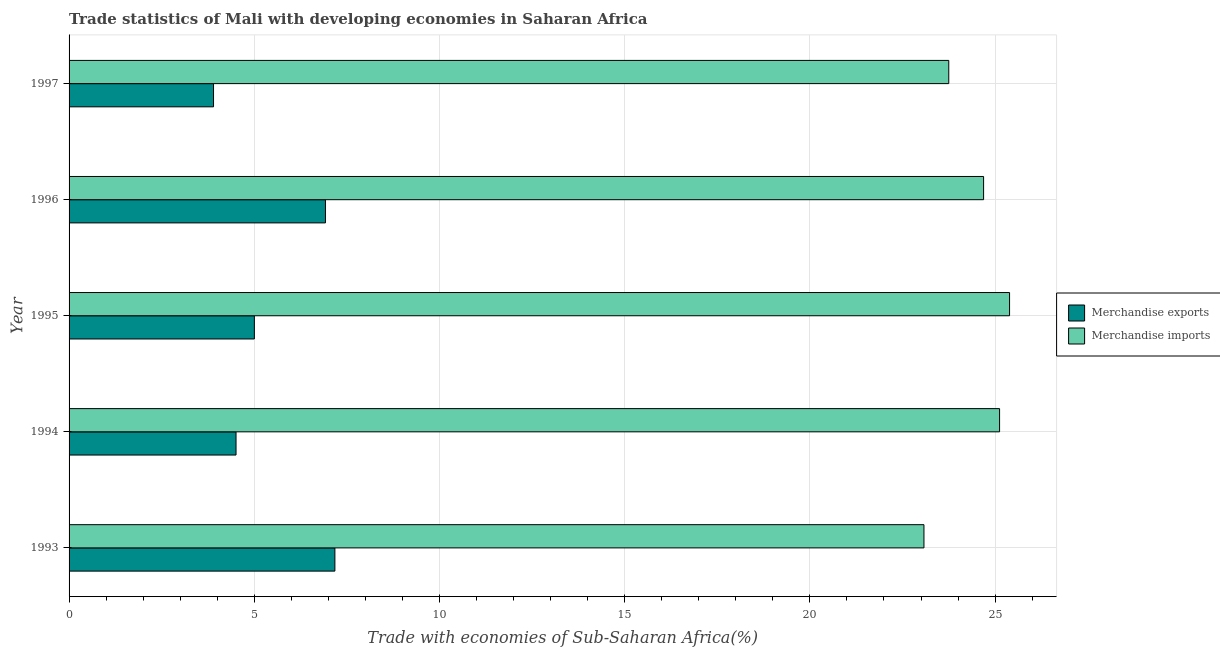How many groups of bars are there?
Offer a very short reply. 5. Are the number of bars per tick equal to the number of legend labels?
Make the answer very short. Yes. How many bars are there on the 1st tick from the top?
Offer a terse response. 2. How many bars are there on the 1st tick from the bottom?
Keep it short and to the point. 2. What is the label of the 2nd group of bars from the top?
Offer a very short reply. 1996. What is the merchandise exports in 1994?
Your answer should be very brief. 4.51. Across all years, what is the maximum merchandise imports?
Provide a short and direct response. 25.39. Across all years, what is the minimum merchandise imports?
Ensure brevity in your answer.  23.08. In which year was the merchandise exports maximum?
Give a very brief answer. 1993. What is the total merchandise exports in the graph?
Your answer should be very brief. 27.51. What is the difference between the merchandise imports in 1994 and that in 1996?
Provide a succinct answer. 0.43. What is the difference between the merchandise exports in 1994 and the merchandise imports in 1996?
Your answer should be very brief. -20.18. What is the average merchandise exports per year?
Make the answer very short. 5.5. In the year 1993, what is the difference between the merchandise exports and merchandise imports?
Your answer should be very brief. -15.9. What is the ratio of the merchandise exports in 1994 to that in 1997?
Ensure brevity in your answer.  1.16. Is the difference between the merchandise exports in 1995 and 1997 greater than the difference between the merchandise imports in 1995 and 1997?
Offer a very short reply. No. What is the difference between the highest and the second highest merchandise exports?
Offer a very short reply. 0.26. What is the difference between the highest and the lowest merchandise imports?
Your response must be concise. 2.31. In how many years, is the merchandise exports greater than the average merchandise exports taken over all years?
Keep it short and to the point. 2. Is the sum of the merchandise exports in 1993 and 1994 greater than the maximum merchandise imports across all years?
Ensure brevity in your answer.  No. What does the 1st bar from the bottom in 1993 represents?
Offer a very short reply. Merchandise exports. Are the values on the major ticks of X-axis written in scientific E-notation?
Your answer should be very brief. No. Does the graph contain grids?
Provide a short and direct response. Yes. Where does the legend appear in the graph?
Ensure brevity in your answer.  Center right. How many legend labels are there?
Your response must be concise. 2. What is the title of the graph?
Make the answer very short. Trade statistics of Mali with developing economies in Saharan Africa. What is the label or title of the X-axis?
Give a very brief answer. Trade with economies of Sub-Saharan Africa(%). What is the Trade with economies of Sub-Saharan Africa(%) in Merchandise exports in 1993?
Give a very brief answer. 7.18. What is the Trade with economies of Sub-Saharan Africa(%) of Merchandise imports in 1993?
Offer a very short reply. 23.08. What is the Trade with economies of Sub-Saharan Africa(%) of Merchandise exports in 1994?
Provide a succinct answer. 4.51. What is the Trade with economies of Sub-Saharan Africa(%) in Merchandise imports in 1994?
Make the answer very short. 25.12. What is the Trade with economies of Sub-Saharan Africa(%) of Merchandise exports in 1995?
Offer a very short reply. 5. What is the Trade with economies of Sub-Saharan Africa(%) of Merchandise imports in 1995?
Offer a very short reply. 25.39. What is the Trade with economies of Sub-Saharan Africa(%) in Merchandise exports in 1996?
Your answer should be very brief. 6.92. What is the Trade with economies of Sub-Saharan Africa(%) of Merchandise imports in 1996?
Your answer should be compact. 24.69. What is the Trade with economies of Sub-Saharan Africa(%) of Merchandise exports in 1997?
Make the answer very short. 3.9. What is the Trade with economies of Sub-Saharan Africa(%) in Merchandise imports in 1997?
Your answer should be very brief. 23.75. Across all years, what is the maximum Trade with economies of Sub-Saharan Africa(%) in Merchandise exports?
Ensure brevity in your answer.  7.18. Across all years, what is the maximum Trade with economies of Sub-Saharan Africa(%) of Merchandise imports?
Your answer should be compact. 25.39. Across all years, what is the minimum Trade with economies of Sub-Saharan Africa(%) of Merchandise exports?
Provide a short and direct response. 3.9. Across all years, what is the minimum Trade with economies of Sub-Saharan Africa(%) in Merchandise imports?
Your answer should be very brief. 23.08. What is the total Trade with economies of Sub-Saharan Africa(%) of Merchandise exports in the graph?
Your answer should be compact. 27.51. What is the total Trade with economies of Sub-Saharan Africa(%) in Merchandise imports in the graph?
Your response must be concise. 122.03. What is the difference between the Trade with economies of Sub-Saharan Africa(%) in Merchandise exports in 1993 and that in 1994?
Make the answer very short. 2.67. What is the difference between the Trade with economies of Sub-Saharan Africa(%) of Merchandise imports in 1993 and that in 1994?
Give a very brief answer. -2.04. What is the difference between the Trade with economies of Sub-Saharan Africa(%) of Merchandise exports in 1993 and that in 1995?
Your response must be concise. 2.17. What is the difference between the Trade with economies of Sub-Saharan Africa(%) in Merchandise imports in 1993 and that in 1995?
Provide a short and direct response. -2.31. What is the difference between the Trade with economies of Sub-Saharan Africa(%) in Merchandise exports in 1993 and that in 1996?
Ensure brevity in your answer.  0.25. What is the difference between the Trade with economies of Sub-Saharan Africa(%) in Merchandise imports in 1993 and that in 1996?
Provide a short and direct response. -1.61. What is the difference between the Trade with economies of Sub-Saharan Africa(%) of Merchandise exports in 1993 and that in 1997?
Keep it short and to the point. 3.28. What is the difference between the Trade with economies of Sub-Saharan Africa(%) of Merchandise imports in 1993 and that in 1997?
Make the answer very short. -0.67. What is the difference between the Trade with economies of Sub-Saharan Africa(%) of Merchandise exports in 1994 and that in 1995?
Provide a succinct answer. -0.49. What is the difference between the Trade with economies of Sub-Saharan Africa(%) of Merchandise imports in 1994 and that in 1995?
Your answer should be compact. -0.27. What is the difference between the Trade with economies of Sub-Saharan Africa(%) in Merchandise exports in 1994 and that in 1996?
Give a very brief answer. -2.41. What is the difference between the Trade with economies of Sub-Saharan Africa(%) of Merchandise imports in 1994 and that in 1996?
Your answer should be compact. 0.43. What is the difference between the Trade with economies of Sub-Saharan Africa(%) of Merchandise exports in 1994 and that in 1997?
Provide a short and direct response. 0.61. What is the difference between the Trade with economies of Sub-Saharan Africa(%) of Merchandise imports in 1994 and that in 1997?
Provide a short and direct response. 1.37. What is the difference between the Trade with economies of Sub-Saharan Africa(%) in Merchandise exports in 1995 and that in 1996?
Ensure brevity in your answer.  -1.92. What is the difference between the Trade with economies of Sub-Saharan Africa(%) of Merchandise imports in 1995 and that in 1996?
Your response must be concise. 0.7. What is the difference between the Trade with economies of Sub-Saharan Africa(%) of Merchandise exports in 1995 and that in 1997?
Provide a short and direct response. 1.1. What is the difference between the Trade with economies of Sub-Saharan Africa(%) of Merchandise imports in 1995 and that in 1997?
Provide a short and direct response. 1.64. What is the difference between the Trade with economies of Sub-Saharan Africa(%) in Merchandise exports in 1996 and that in 1997?
Offer a terse response. 3.02. What is the difference between the Trade with economies of Sub-Saharan Africa(%) of Merchandise imports in 1996 and that in 1997?
Ensure brevity in your answer.  0.94. What is the difference between the Trade with economies of Sub-Saharan Africa(%) of Merchandise exports in 1993 and the Trade with economies of Sub-Saharan Africa(%) of Merchandise imports in 1994?
Give a very brief answer. -17.94. What is the difference between the Trade with economies of Sub-Saharan Africa(%) in Merchandise exports in 1993 and the Trade with economies of Sub-Saharan Africa(%) in Merchandise imports in 1995?
Your response must be concise. -18.21. What is the difference between the Trade with economies of Sub-Saharan Africa(%) in Merchandise exports in 1993 and the Trade with economies of Sub-Saharan Africa(%) in Merchandise imports in 1996?
Offer a very short reply. -17.51. What is the difference between the Trade with economies of Sub-Saharan Africa(%) of Merchandise exports in 1993 and the Trade with economies of Sub-Saharan Africa(%) of Merchandise imports in 1997?
Offer a terse response. -16.57. What is the difference between the Trade with economies of Sub-Saharan Africa(%) in Merchandise exports in 1994 and the Trade with economies of Sub-Saharan Africa(%) in Merchandise imports in 1995?
Provide a succinct answer. -20.88. What is the difference between the Trade with economies of Sub-Saharan Africa(%) in Merchandise exports in 1994 and the Trade with economies of Sub-Saharan Africa(%) in Merchandise imports in 1996?
Provide a short and direct response. -20.18. What is the difference between the Trade with economies of Sub-Saharan Africa(%) in Merchandise exports in 1994 and the Trade with economies of Sub-Saharan Africa(%) in Merchandise imports in 1997?
Offer a very short reply. -19.24. What is the difference between the Trade with economies of Sub-Saharan Africa(%) in Merchandise exports in 1995 and the Trade with economies of Sub-Saharan Africa(%) in Merchandise imports in 1996?
Offer a very short reply. -19.69. What is the difference between the Trade with economies of Sub-Saharan Africa(%) in Merchandise exports in 1995 and the Trade with economies of Sub-Saharan Africa(%) in Merchandise imports in 1997?
Your answer should be very brief. -18.75. What is the difference between the Trade with economies of Sub-Saharan Africa(%) of Merchandise exports in 1996 and the Trade with economies of Sub-Saharan Africa(%) of Merchandise imports in 1997?
Provide a succinct answer. -16.83. What is the average Trade with economies of Sub-Saharan Africa(%) of Merchandise exports per year?
Make the answer very short. 5.5. What is the average Trade with economies of Sub-Saharan Africa(%) of Merchandise imports per year?
Your answer should be very brief. 24.41. In the year 1993, what is the difference between the Trade with economies of Sub-Saharan Africa(%) of Merchandise exports and Trade with economies of Sub-Saharan Africa(%) of Merchandise imports?
Your answer should be compact. -15.9. In the year 1994, what is the difference between the Trade with economies of Sub-Saharan Africa(%) in Merchandise exports and Trade with economies of Sub-Saharan Africa(%) in Merchandise imports?
Your answer should be compact. -20.61. In the year 1995, what is the difference between the Trade with economies of Sub-Saharan Africa(%) of Merchandise exports and Trade with economies of Sub-Saharan Africa(%) of Merchandise imports?
Ensure brevity in your answer.  -20.39. In the year 1996, what is the difference between the Trade with economies of Sub-Saharan Africa(%) of Merchandise exports and Trade with economies of Sub-Saharan Africa(%) of Merchandise imports?
Your answer should be very brief. -17.77. In the year 1997, what is the difference between the Trade with economies of Sub-Saharan Africa(%) of Merchandise exports and Trade with economies of Sub-Saharan Africa(%) of Merchandise imports?
Provide a short and direct response. -19.85. What is the ratio of the Trade with economies of Sub-Saharan Africa(%) in Merchandise exports in 1993 to that in 1994?
Provide a short and direct response. 1.59. What is the ratio of the Trade with economies of Sub-Saharan Africa(%) in Merchandise imports in 1993 to that in 1994?
Provide a short and direct response. 0.92. What is the ratio of the Trade with economies of Sub-Saharan Africa(%) in Merchandise exports in 1993 to that in 1995?
Ensure brevity in your answer.  1.43. What is the ratio of the Trade with economies of Sub-Saharan Africa(%) in Merchandise imports in 1993 to that in 1995?
Give a very brief answer. 0.91. What is the ratio of the Trade with economies of Sub-Saharan Africa(%) of Merchandise exports in 1993 to that in 1996?
Provide a succinct answer. 1.04. What is the ratio of the Trade with economies of Sub-Saharan Africa(%) of Merchandise imports in 1993 to that in 1996?
Ensure brevity in your answer.  0.93. What is the ratio of the Trade with economies of Sub-Saharan Africa(%) in Merchandise exports in 1993 to that in 1997?
Provide a short and direct response. 1.84. What is the ratio of the Trade with economies of Sub-Saharan Africa(%) in Merchandise imports in 1993 to that in 1997?
Make the answer very short. 0.97. What is the ratio of the Trade with economies of Sub-Saharan Africa(%) in Merchandise exports in 1994 to that in 1995?
Give a very brief answer. 0.9. What is the ratio of the Trade with economies of Sub-Saharan Africa(%) of Merchandise imports in 1994 to that in 1995?
Your response must be concise. 0.99. What is the ratio of the Trade with economies of Sub-Saharan Africa(%) of Merchandise exports in 1994 to that in 1996?
Give a very brief answer. 0.65. What is the ratio of the Trade with economies of Sub-Saharan Africa(%) in Merchandise imports in 1994 to that in 1996?
Offer a very short reply. 1.02. What is the ratio of the Trade with economies of Sub-Saharan Africa(%) of Merchandise exports in 1994 to that in 1997?
Offer a terse response. 1.16. What is the ratio of the Trade with economies of Sub-Saharan Africa(%) of Merchandise imports in 1994 to that in 1997?
Your answer should be compact. 1.06. What is the ratio of the Trade with economies of Sub-Saharan Africa(%) in Merchandise exports in 1995 to that in 1996?
Your answer should be very brief. 0.72. What is the ratio of the Trade with economies of Sub-Saharan Africa(%) in Merchandise imports in 1995 to that in 1996?
Your response must be concise. 1.03. What is the ratio of the Trade with economies of Sub-Saharan Africa(%) in Merchandise exports in 1995 to that in 1997?
Keep it short and to the point. 1.28. What is the ratio of the Trade with economies of Sub-Saharan Africa(%) of Merchandise imports in 1995 to that in 1997?
Keep it short and to the point. 1.07. What is the ratio of the Trade with economies of Sub-Saharan Africa(%) in Merchandise exports in 1996 to that in 1997?
Give a very brief answer. 1.77. What is the ratio of the Trade with economies of Sub-Saharan Africa(%) of Merchandise imports in 1996 to that in 1997?
Your answer should be very brief. 1.04. What is the difference between the highest and the second highest Trade with economies of Sub-Saharan Africa(%) in Merchandise exports?
Your response must be concise. 0.25. What is the difference between the highest and the second highest Trade with economies of Sub-Saharan Africa(%) in Merchandise imports?
Ensure brevity in your answer.  0.27. What is the difference between the highest and the lowest Trade with economies of Sub-Saharan Africa(%) in Merchandise exports?
Offer a very short reply. 3.28. What is the difference between the highest and the lowest Trade with economies of Sub-Saharan Africa(%) of Merchandise imports?
Give a very brief answer. 2.31. 